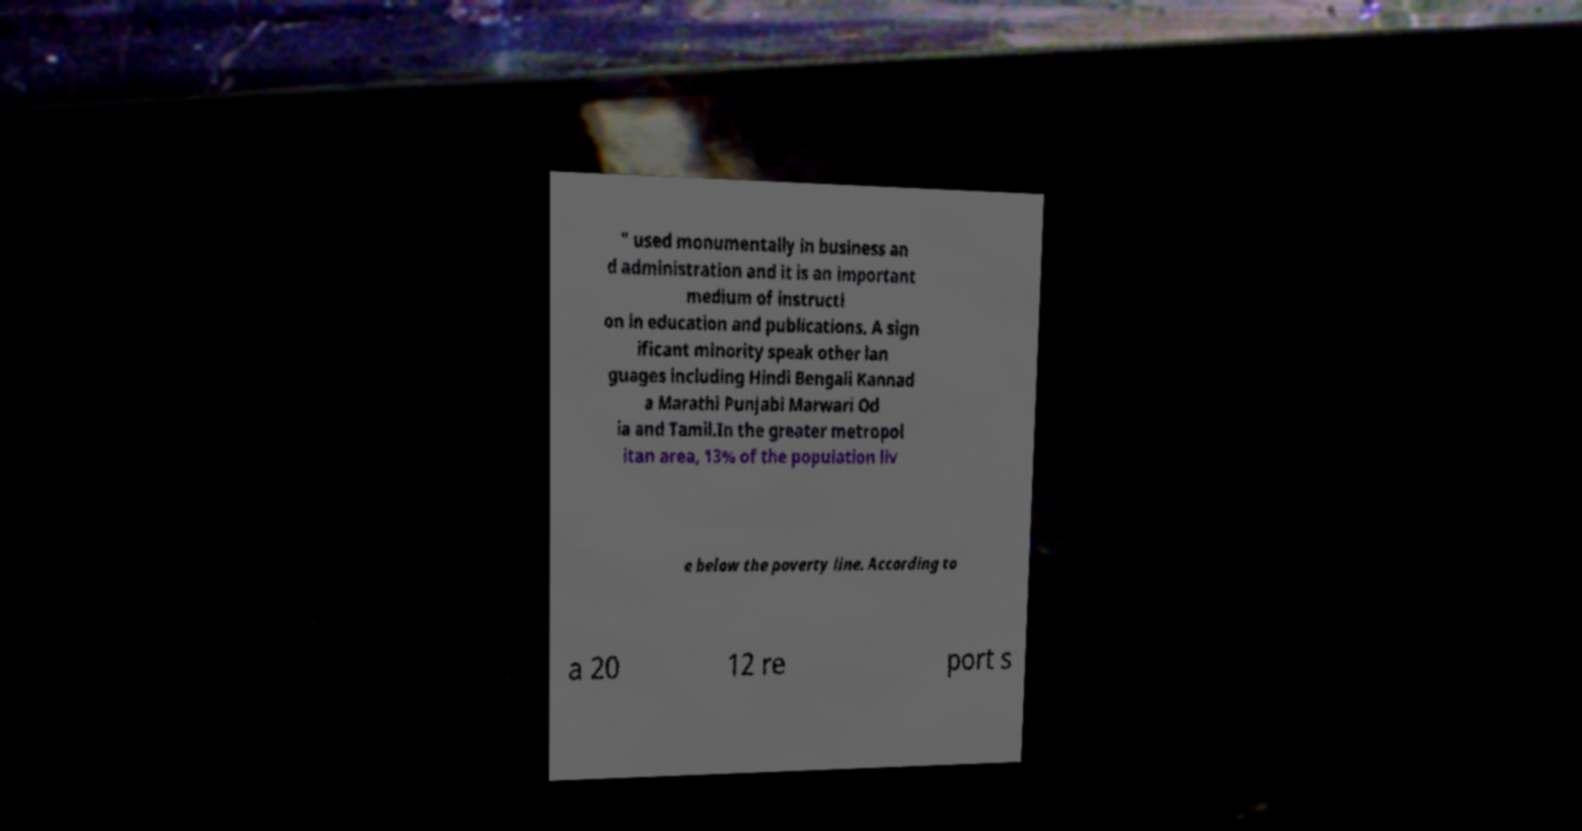I need the written content from this picture converted into text. Can you do that? " used monumentally in business an d administration and it is an important medium of instructi on in education and publications. A sign ificant minority speak other lan guages including Hindi Bengali Kannad a Marathi Punjabi Marwari Od ia and Tamil.In the greater metropol itan area, 13% of the population liv e below the poverty line. According to a 20 12 re port s 